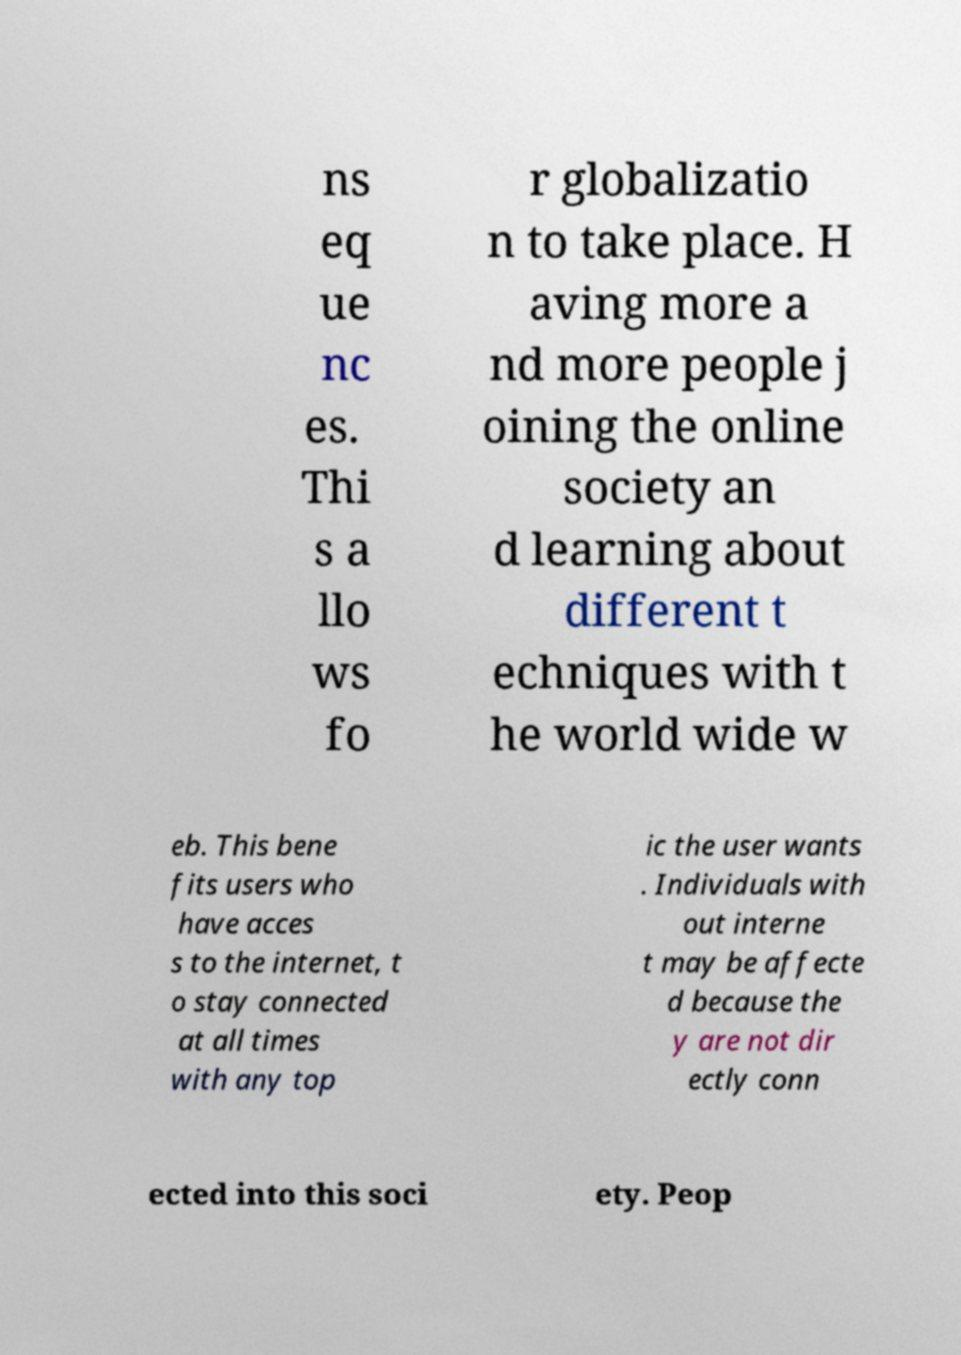Could you assist in decoding the text presented in this image and type it out clearly? ns eq ue nc es. Thi s a llo ws fo r globalizatio n to take place. H aving more a nd more people j oining the online society an d learning about different t echniques with t he world wide w eb. This bene fits users who have acces s to the internet, t o stay connected at all times with any top ic the user wants . Individuals with out interne t may be affecte d because the y are not dir ectly conn ected into this soci ety. Peop 